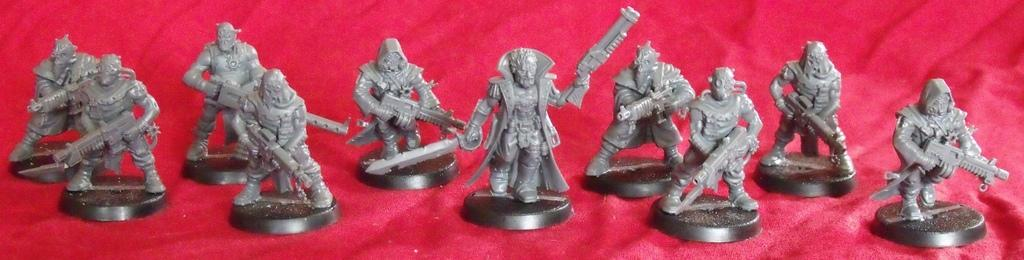What type of objects are in the foreground of the image? There are toy statues in the foreground of the image. What color is the surface on which the toy statues are placed? The toy statues are on a red surface. What direction do the toy statues show authority in the image? There is no indication of authority or direction in the image; it simply features toy statues on a red surface. 